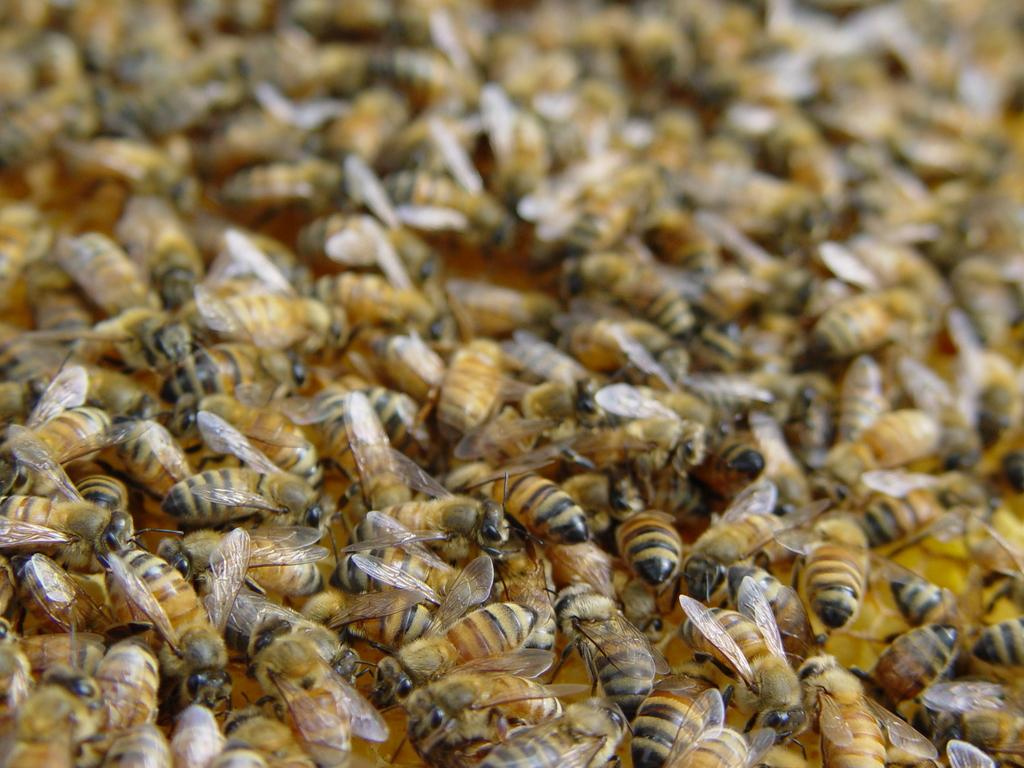What type of animals are present in the image? There is a group of bees in the image. Where are the bees located? The bees are on the ground. How many bikes are visible in the image? There are no bikes present in the image; it features a group of bees on the ground. What type of currency can be seen in the image? There is no currency, such as a dime, present in the image. 